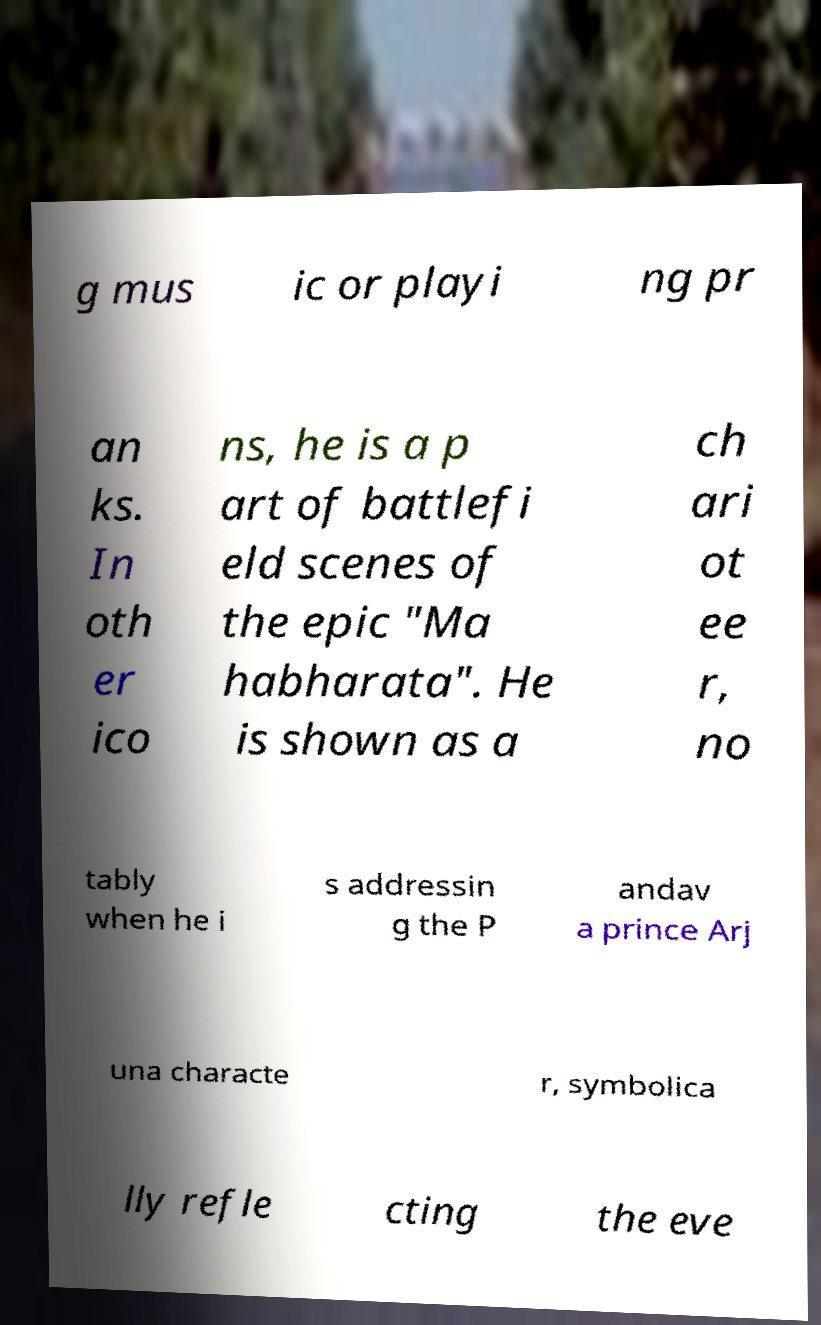What messages or text are displayed in this image? I need them in a readable, typed format. g mus ic or playi ng pr an ks. In oth er ico ns, he is a p art of battlefi eld scenes of the epic "Ma habharata". He is shown as a ch ari ot ee r, no tably when he i s addressin g the P andav a prince Arj una characte r, symbolica lly refle cting the eve 